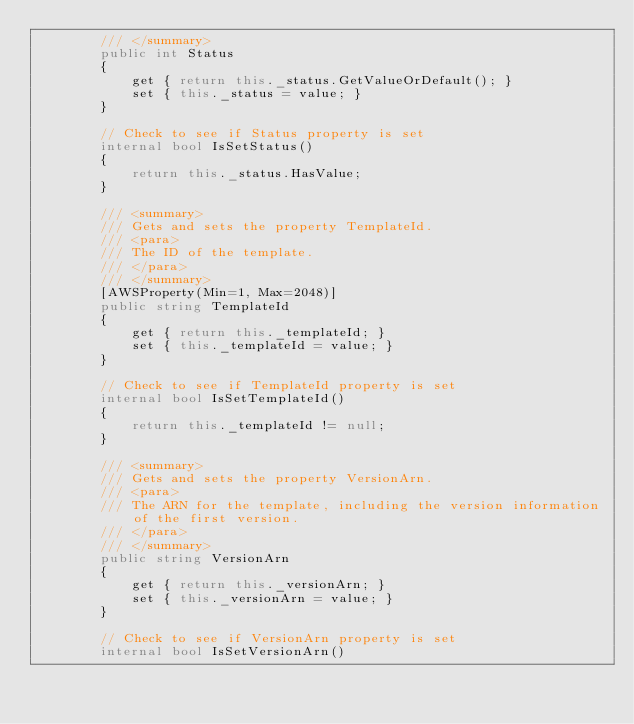Convert code to text. <code><loc_0><loc_0><loc_500><loc_500><_C#_>        /// </summary>
        public int Status
        {
            get { return this._status.GetValueOrDefault(); }
            set { this._status = value; }
        }

        // Check to see if Status property is set
        internal bool IsSetStatus()
        {
            return this._status.HasValue; 
        }

        /// <summary>
        /// Gets and sets the property TemplateId. 
        /// <para>
        /// The ID of the template.
        /// </para>
        /// </summary>
        [AWSProperty(Min=1, Max=2048)]
        public string TemplateId
        {
            get { return this._templateId; }
            set { this._templateId = value; }
        }

        // Check to see if TemplateId property is set
        internal bool IsSetTemplateId()
        {
            return this._templateId != null;
        }

        /// <summary>
        /// Gets and sets the property VersionArn. 
        /// <para>
        /// The ARN for the template, including the version information of the first version.
        /// </para>
        /// </summary>
        public string VersionArn
        {
            get { return this._versionArn; }
            set { this._versionArn = value; }
        }

        // Check to see if VersionArn property is set
        internal bool IsSetVersionArn()</code> 